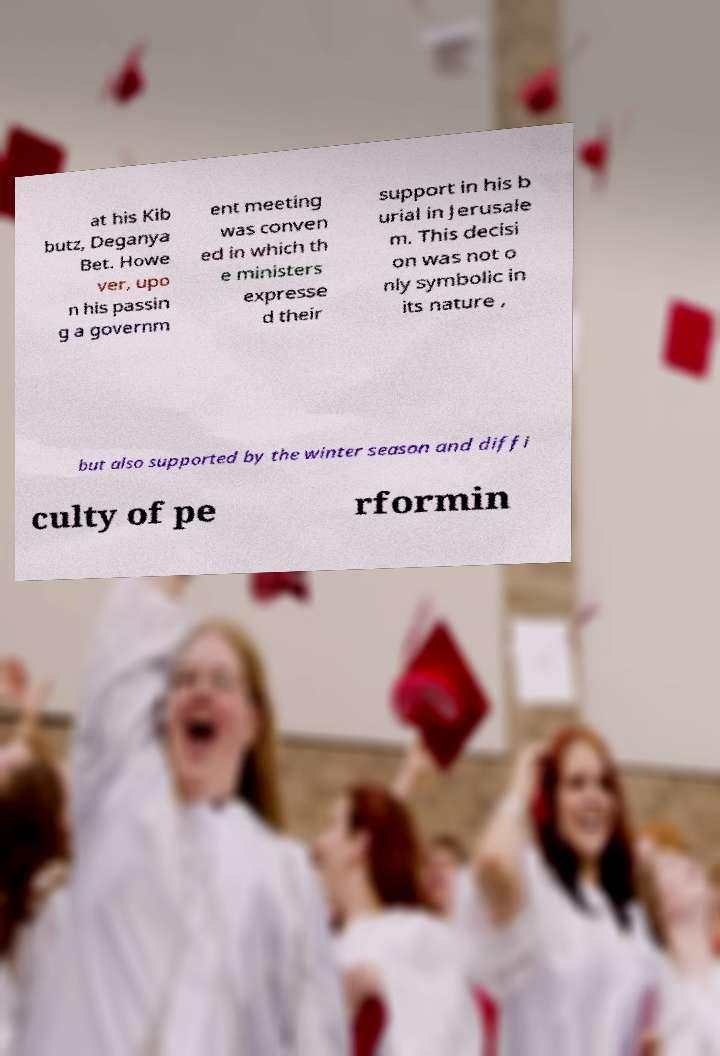For documentation purposes, I need the text within this image transcribed. Could you provide that? at his Kib butz, Deganya Bet. Howe ver, upo n his passin g a governm ent meeting was conven ed in which th e ministers expresse d their support in his b urial in Jerusale m. This decisi on was not o nly symbolic in its nature , but also supported by the winter season and diffi culty of pe rformin 